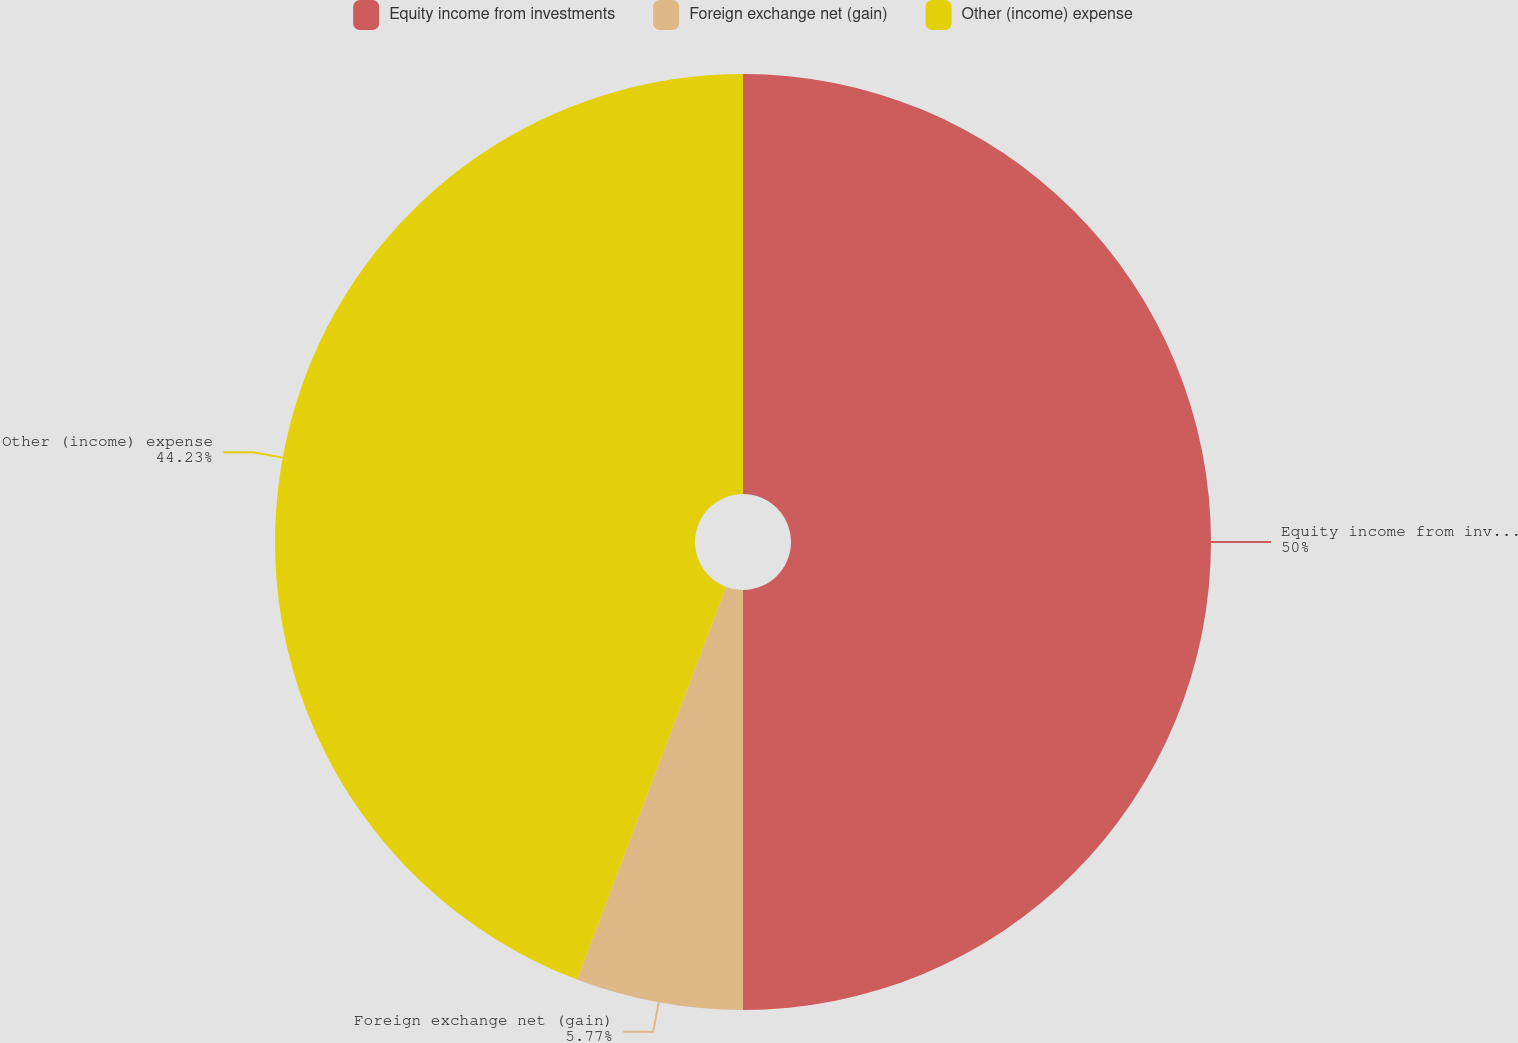Convert chart to OTSL. <chart><loc_0><loc_0><loc_500><loc_500><pie_chart><fcel>Equity income from investments<fcel>Foreign exchange net (gain)<fcel>Other (income) expense<nl><fcel>50.0%<fcel>5.77%<fcel>44.23%<nl></chart> 